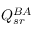<formula> <loc_0><loc_0><loc_500><loc_500>Q _ { s r } ^ { B A }</formula> 